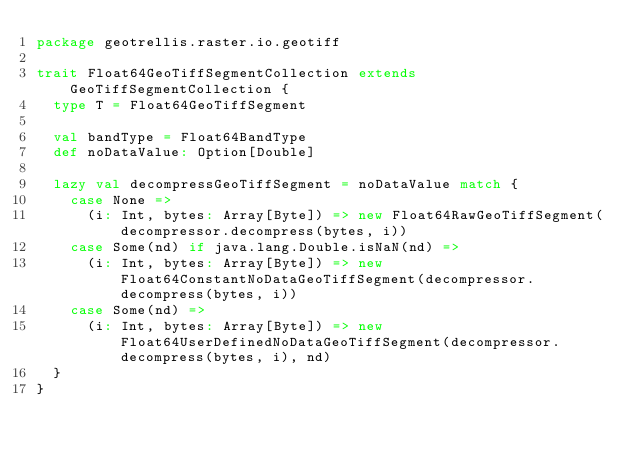Convert code to text. <code><loc_0><loc_0><loc_500><loc_500><_Scala_>package geotrellis.raster.io.geotiff

trait Float64GeoTiffSegmentCollection extends GeoTiffSegmentCollection {
  type T = Float64GeoTiffSegment

  val bandType = Float64BandType
  def noDataValue: Option[Double]

  lazy val decompressGeoTiffSegment = noDataValue match {
    case None =>
      (i: Int, bytes: Array[Byte]) => new Float64RawGeoTiffSegment(decompressor.decompress(bytes, i))
    case Some(nd) if java.lang.Double.isNaN(nd) =>
      (i: Int, bytes: Array[Byte]) => new Float64ConstantNoDataGeoTiffSegment(decompressor.decompress(bytes, i))
    case Some(nd) =>
      (i: Int, bytes: Array[Byte]) => new Float64UserDefinedNoDataGeoTiffSegment(decompressor.decompress(bytes, i), nd)
  }
}
</code> 